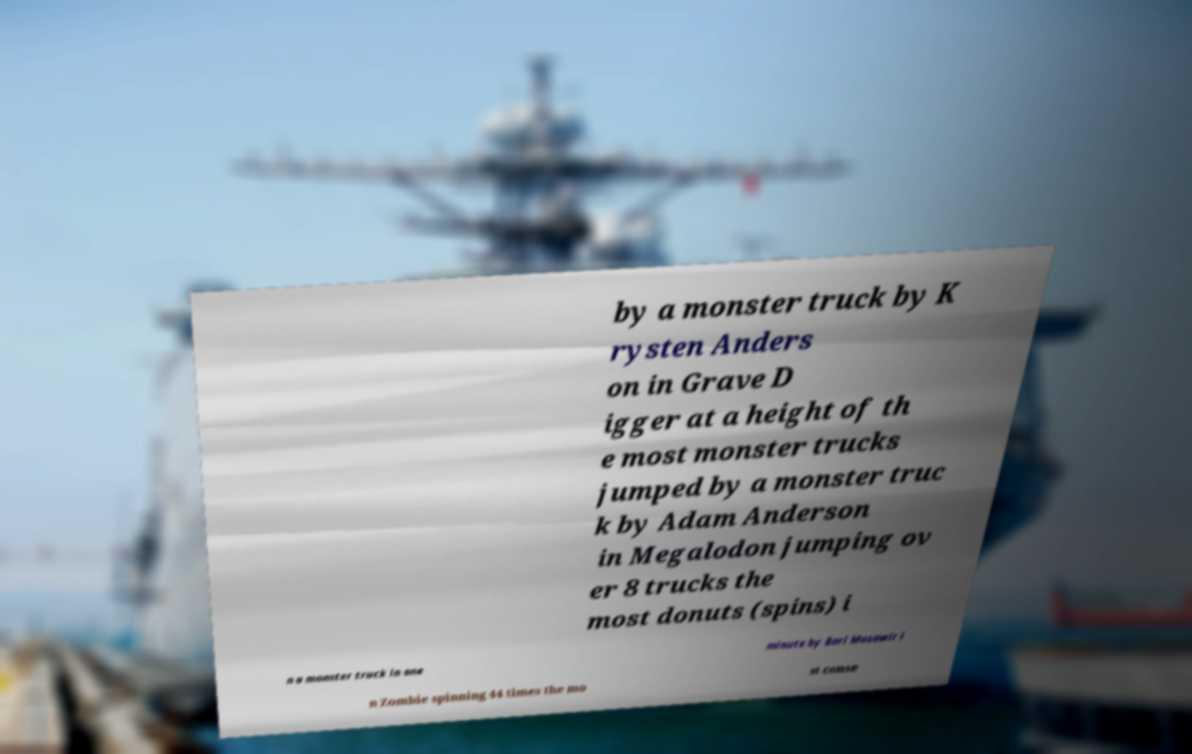I need the written content from this picture converted into text. Can you do that? by a monster truck by K rysten Anders on in Grave D igger at a height of th e most monster trucks jumped by a monster truc k by Adam Anderson in Megalodon jumping ov er 8 trucks the most donuts (spins) i n a monster truck in one minute by Bari Musawir i n Zombie spinning 44 times the mo st conse 